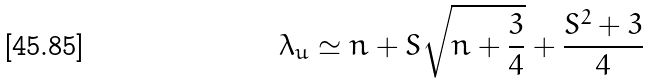<formula> <loc_0><loc_0><loc_500><loc_500>\lambda _ { u } \simeq n + S \sqrt { n + \frac { 3 } { 4 } } + \frac { S ^ { 2 } + 3 } { 4 }</formula> 